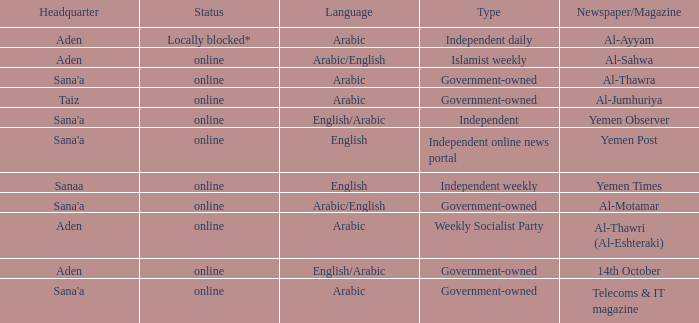Where can the main office of al-jumhuriya, a government-owned publication, be found? Taiz. 